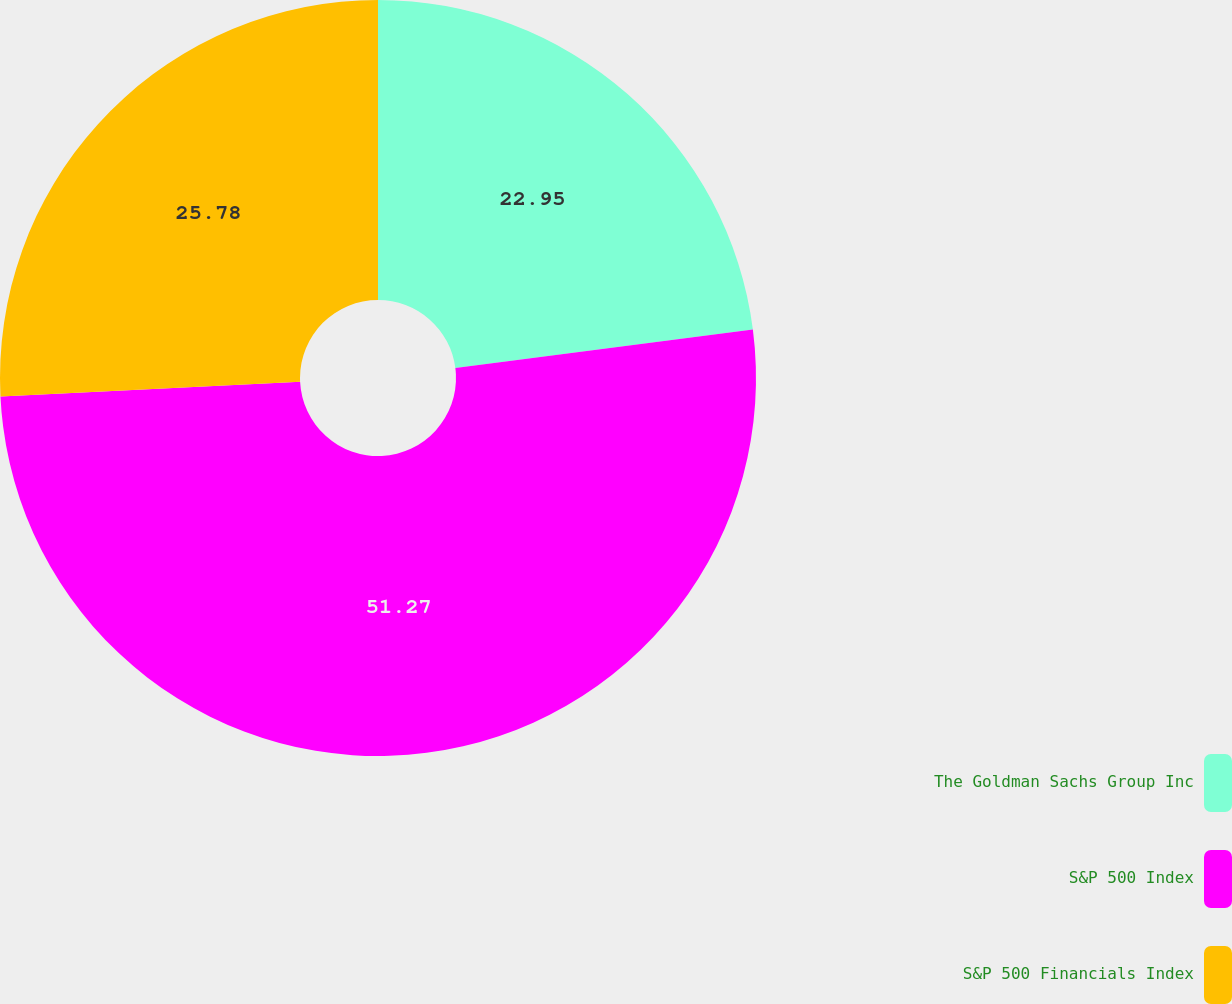Convert chart to OTSL. <chart><loc_0><loc_0><loc_500><loc_500><pie_chart><fcel>The Goldman Sachs Group Inc<fcel>S&P 500 Index<fcel>S&P 500 Financials Index<nl><fcel>22.95%<fcel>51.27%<fcel>25.78%<nl></chart> 